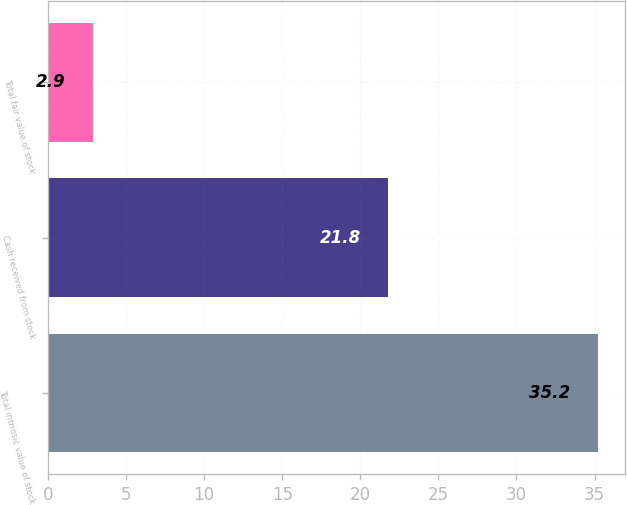Convert chart to OTSL. <chart><loc_0><loc_0><loc_500><loc_500><bar_chart><fcel>Total intrinsic value of stock<fcel>Cash received from stock<fcel>Total fair value of stock<nl><fcel>35.2<fcel>21.8<fcel>2.9<nl></chart> 